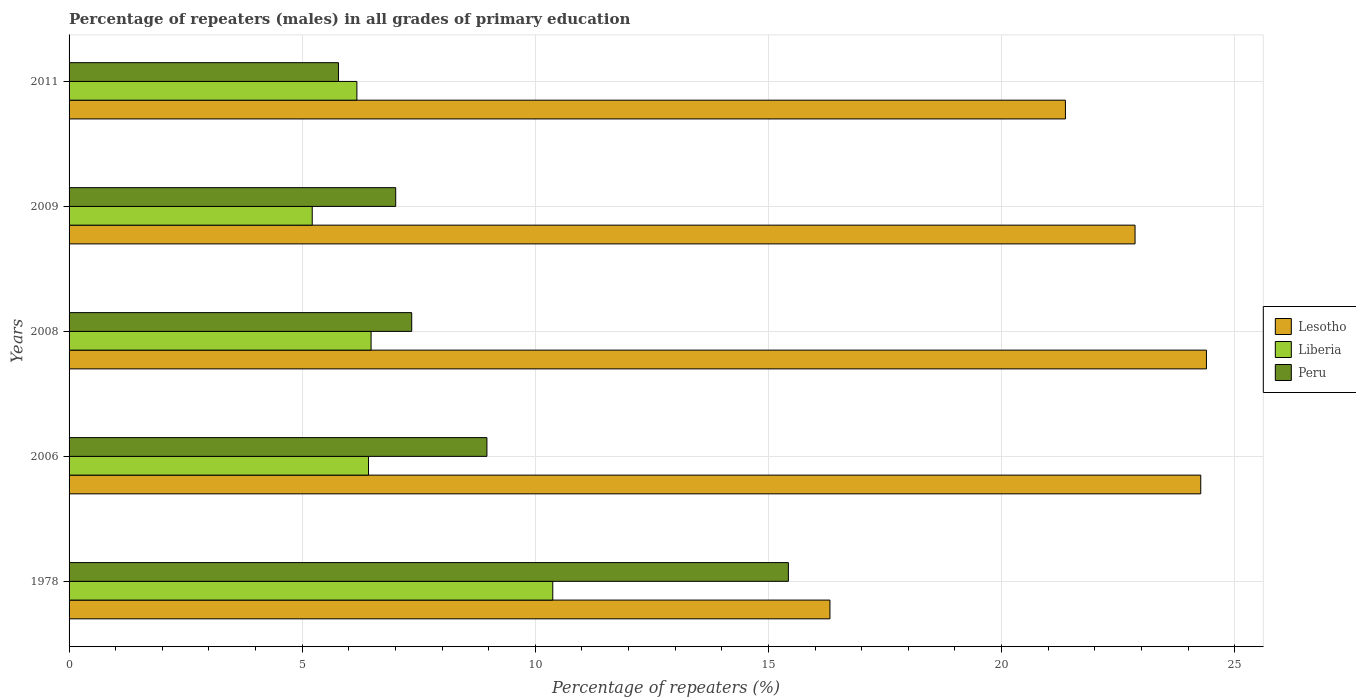How many groups of bars are there?
Offer a very short reply. 5. Are the number of bars on each tick of the Y-axis equal?
Provide a succinct answer. Yes. How many bars are there on the 3rd tick from the top?
Offer a very short reply. 3. How many bars are there on the 1st tick from the bottom?
Ensure brevity in your answer.  3. In how many cases, is the number of bars for a given year not equal to the number of legend labels?
Provide a short and direct response. 0. What is the percentage of repeaters (males) in Lesotho in 2011?
Your response must be concise. 21.37. Across all years, what is the maximum percentage of repeaters (males) in Lesotho?
Your answer should be very brief. 24.39. Across all years, what is the minimum percentage of repeaters (males) in Lesotho?
Keep it short and to the point. 16.32. In which year was the percentage of repeaters (males) in Peru maximum?
Keep it short and to the point. 1978. In which year was the percentage of repeaters (males) in Peru minimum?
Your answer should be very brief. 2011. What is the total percentage of repeaters (males) in Peru in the graph?
Make the answer very short. 44.52. What is the difference between the percentage of repeaters (males) in Peru in 1978 and that in 2006?
Offer a very short reply. 6.47. What is the difference between the percentage of repeaters (males) in Lesotho in 2006 and the percentage of repeaters (males) in Liberia in 2008?
Ensure brevity in your answer.  17.79. What is the average percentage of repeaters (males) in Lesotho per year?
Your response must be concise. 21.84. In the year 2011, what is the difference between the percentage of repeaters (males) in Peru and percentage of repeaters (males) in Liberia?
Your answer should be very brief. -0.4. In how many years, is the percentage of repeaters (males) in Lesotho greater than 16 %?
Your answer should be compact. 5. What is the ratio of the percentage of repeaters (males) in Lesotho in 2008 to that in 2011?
Your answer should be very brief. 1.14. What is the difference between the highest and the second highest percentage of repeaters (males) in Lesotho?
Make the answer very short. 0.12. What is the difference between the highest and the lowest percentage of repeaters (males) in Lesotho?
Offer a very short reply. 8.07. Is the sum of the percentage of repeaters (males) in Liberia in 2009 and 2011 greater than the maximum percentage of repeaters (males) in Peru across all years?
Offer a very short reply. No. What does the 2nd bar from the top in 2011 represents?
Offer a very short reply. Liberia. What does the 3rd bar from the bottom in 2006 represents?
Keep it short and to the point. Peru. Are all the bars in the graph horizontal?
Your answer should be very brief. Yes. Are the values on the major ticks of X-axis written in scientific E-notation?
Keep it short and to the point. No. Where does the legend appear in the graph?
Offer a terse response. Center right. How many legend labels are there?
Provide a succinct answer. 3. How are the legend labels stacked?
Keep it short and to the point. Vertical. What is the title of the graph?
Make the answer very short. Percentage of repeaters (males) in all grades of primary education. What is the label or title of the X-axis?
Ensure brevity in your answer.  Percentage of repeaters (%). What is the Percentage of repeaters (%) in Lesotho in 1978?
Provide a short and direct response. 16.32. What is the Percentage of repeaters (%) of Liberia in 1978?
Your answer should be very brief. 10.37. What is the Percentage of repeaters (%) of Peru in 1978?
Keep it short and to the point. 15.43. What is the Percentage of repeaters (%) of Lesotho in 2006?
Your answer should be compact. 24.27. What is the Percentage of repeaters (%) of Liberia in 2006?
Your answer should be very brief. 6.42. What is the Percentage of repeaters (%) of Peru in 2006?
Give a very brief answer. 8.96. What is the Percentage of repeaters (%) of Lesotho in 2008?
Provide a short and direct response. 24.39. What is the Percentage of repeaters (%) of Liberia in 2008?
Your answer should be very brief. 6.48. What is the Percentage of repeaters (%) of Peru in 2008?
Offer a terse response. 7.35. What is the Percentage of repeaters (%) of Lesotho in 2009?
Give a very brief answer. 22.86. What is the Percentage of repeaters (%) of Liberia in 2009?
Provide a short and direct response. 5.22. What is the Percentage of repeaters (%) in Peru in 2009?
Keep it short and to the point. 7.01. What is the Percentage of repeaters (%) of Lesotho in 2011?
Offer a very short reply. 21.37. What is the Percentage of repeaters (%) in Liberia in 2011?
Your response must be concise. 6.17. What is the Percentage of repeaters (%) in Peru in 2011?
Keep it short and to the point. 5.78. Across all years, what is the maximum Percentage of repeaters (%) of Lesotho?
Your answer should be very brief. 24.39. Across all years, what is the maximum Percentage of repeaters (%) of Liberia?
Keep it short and to the point. 10.37. Across all years, what is the maximum Percentage of repeaters (%) of Peru?
Offer a terse response. 15.43. Across all years, what is the minimum Percentage of repeaters (%) of Lesotho?
Your response must be concise. 16.32. Across all years, what is the minimum Percentage of repeaters (%) in Liberia?
Your answer should be very brief. 5.22. Across all years, what is the minimum Percentage of repeaters (%) in Peru?
Your answer should be compact. 5.78. What is the total Percentage of repeaters (%) of Lesotho in the graph?
Provide a succinct answer. 109.21. What is the total Percentage of repeaters (%) of Liberia in the graph?
Give a very brief answer. 34.66. What is the total Percentage of repeaters (%) of Peru in the graph?
Your answer should be compact. 44.52. What is the difference between the Percentage of repeaters (%) of Lesotho in 1978 and that in 2006?
Make the answer very short. -7.95. What is the difference between the Percentage of repeaters (%) in Liberia in 1978 and that in 2006?
Your response must be concise. 3.95. What is the difference between the Percentage of repeaters (%) of Peru in 1978 and that in 2006?
Provide a short and direct response. 6.47. What is the difference between the Percentage of repeaters (%) of Lesotho in 1978 and that in 2008?
Offer a terse response. -8.07. What is the difference between the Percentage of repeaters (%) of Liberia in 1978 and that in 2008?
Offer a terse response. 3.9. What is the difference between the Percentage of repeaters (%) in Peru in 1978 and that in 2008?
Provide a short and direct response. 8.08. What is the difference between the Percentage of repeaters (%) of Lesotho in 1978 and that in 2009?
Offer a terse response. -6.54. What is the difference between the Percentage of repeaters (%) in Liberia in 1978 and that in 2009?
Make the answer very short. 5.16. What is the difference between the Percentage of repeaters (%) in Peru in 1978 and that in 2009?
Ensure brevity in your answer.  8.42. What is the difference between the Percentage of repeaters (%) of Lesotho in 1978 and that in 2011?
Ensure brevity in your answer.  -5.05. What is the difference between the Percentage of repeaters (%) of Liberia in 1978 and that in 2011?
Provide a short and direct response. 4.2. What is the difference between the Percentage of repeaters (%) of Peru in 1978 and that in 2011?
Ensure brevity in your answer.  9.65. What is the difference between the Percentage of repeaters (%) in Lesotho in 2006 and that in 2008?
Make the answer very short. -0.12. What is the difference between the Percentage of repeaters (%) of Liberia in 2006 and that in 2008?
Your response must be concise. -0.05. What is the difference between the Percentage of repeaters (%) in Peru in 2006 and that in 2008?
Provide a succinct answer. 1.61. What is the difference between the Percentage of repeaters (%) of Lesotho in 2006 and that in 2009?
Your answer should be compact. 1.41. What is the difference between the Percentage of repeaters (%) in Liberia in 2006 and that in 2009?
Keep it short and to the point. 1.21. What is the difference between the Percentage of repeaters (%) in Peru in 2006 and that in 2009?
Provide a short and direct response. 1.96. What is the difference between the Percentage of repeaters (%) in Lesotho in 2006 and that in 2011?
Provide a succinct answer. 2.9. What is the difference between the Percentage of repeaters (%) in Liberia in 2006 and that in 2011?
Provide a short and direct response. 0.25. What is the difference between the Percentage of repeaters (%) in Peru in 2006 and that in 2011?
Provide a succinct answer. 3.18. What is the difference between the Percentage of repeaters (%) of Lesotho in 2008 and that in 2009?
Provide a succinct answer. 1.53. What is the difference between the Percentage of repeaters (%) in Liberia in 2008 and that in 2009?
Provide a succinct answer. 1.26. What is the difference between the Percentage of repeaters (%) of Peru in 2008 and that in 2009?
Your response must be concise. 0.34. What is the difference between the Percentage of repeaters (%) of Lesotho in 2008 and that in 2011?
Give a very brief answer. 3.02. What is the difference between the Percentage of repeaters (%) in Liberia in 2008 and that in 2011?
Provide a short and direct response. 0.3. What is the difference between the Percentage of repeaters (%) of Peru in 2008 and that in 2011?
Keep it short and to the point. 1.57. What is the difference between the Percentage of repeaters (%) of Lesotho in 2009 and that in 2011?
Provide a succinct answer. 1.49. What is the difference between the Percentage of repeaters (%) in Liberia in 2009 and that in 2011?
Ensure brevity in your answer.  -0.96. What is the difference between the Percentage of repeaters (%) in Peru in 2009 and that in 2011?
Offer a very short reply. 1.23. What is the difference between the Percentage of repeaters (%) in Lesotho in 1978 and the Percentage of repeaters (%) in Liberia in 2006?
Make the answer very short. 9.9. What is the difference between the Percentage of repeaters (%) of Lesotho in 1978 and the Percentage of repeaters (%) of Peru in 2006?
Ensure brevity in your answer.  7.36. What is the difference between the Percentage of repeaters (%) in Liberia in 1978 and the Percentage of repeaters (%) in Peru in 2006?
Make the answer very short. 1.41. What is the difference between the Percentage of repeaters (%) of Lesotho in 1978 and the Percentage of repeaters (%) of Liberia in 2008?
Provide a succinct answer. 9.84. What is the difference between the Percentage of repeaters (%) of Lesotho in 1978 and the Percentage of repeaters (%) of Peru in 2008?
Provide a short and direct response. 8.97. What is the difference between the Percentage of repeaters (%) of Liberia in 1978 and the Percentage of repeaters (%) of Peru in 2008?
Your answer should be compact. 3.02. What is the difference between the Percentage of repeaters (%) in Lesotho in 1978 and the Percentage of repeaters (%) in Liberia in 2009?
Offer a very short reply. 11.1. What is the difference between the Percentage of repeaters (%) in Lesotho in 1978 and the Percentage of repeaters (%) in Peru in 2009?
Your answer should be very brief. 9.31. What is the difference between the Percentage of repeaters (%) of Liberia in 1978 and the Percentage of repeaters (%) of Peru in 2009?
Make the answer very short. 3.37. What is the difference between the Percentage of repeaters (%) of Lesotho in 1978 and the Percentage of repeaters (%) of Liberia in 2011?
Offer a very short reply. 10.15. What is the difference between the Percentage of repeaters (%) of Lesotho in 1978 and the Percentage of repeaters (%) of Peru in 2011?
Keep it short and to the point. 10.54. What is the difference between the Percentage of repeaters (%) in Liberia in 1978 and the Percentage of repeaters (%) in Peru in 2011?
Ensure brevity in your answer.  4.6. What is the difference between the Percentage of repeaters (%) in Lesotho in 2006 and the Percentage of repeaters (%) in Liberia in 2008?
Ensure brevity in your answer.  17.79. What is the difference between the Percentage of repeaters (%) in Lesotho in 2006 and the Percentage of repeaters (%) in Peru in 2008?
Your answer should be very brief. 16.92. What is the difference between the Percentage of repeaters (%) of Liberia in 2006 and the Percentage of repeaters (%) of Peru in 2008?
Your answer should be very brief. -0.93. What is the difference between the Percentage of repeaters (%) in Lesotho in 2006 and the Percentage of repeaters (%) in Liberia in 2009?
Your answer should be very brief. 19.06. What is the difference between the Percentage of repeaters (%) in Lesotho in 2006 and the Percentage of repeaters (%) in Peru in 2009?
Your answer should be compact. 17.27. What is the difference between the Percentage of repeaters (%) in Liberia in 2006 and the Percentage of repeaters (%) in Peru in 2009?
Provide a succinct answer. -0.58. What is the difference between the Percentage of repeaters (%) in Lesotho in 2006 and the Percentage of repeaters (%) in Liberia in 2011?
Give a very brief answer. 18.1. What is the difference between the Percentage of repeaters (%) of Lesotho in 2006 and the Percentage of repeaters (%) of Peru in 2011?
Your answer should be compact. 18.49. What is the difference between the Percentage of repeaters (%) of Liberia in 2006 and the Percentage of repeaters (%) of Peru in 2011?
Your response must be concise. 0.64. What is the difference between the Percentage of repeaters (%) of Lesotho in 2008 and the Percentage of repeaters (%) of Liberia in 2009?
Offer a terse response. 19.18. What is the difference between the Percentage of repeaters (%) in Lesotho in 2008 and the Percentage of repeaters (%) in Peru in 2009?
Make the answer very short. 17.39. What is the difference between the Percentage of repeaters (%) of Liberia in 2008 and the Percentage of repeaters (%) of Peru in 2009?
Your answer should be compact. -0.53. What is the difference between the Percentage of repeaters (%) in Lesotho in 2008 and the Percentage of repeaters (%) in Liberia in 2011?
Offer a terse response. 18.22. What is the difference between the Percentage of repeaters (%) in Lesotho in 2008 and the Percentage of repeaters (%) in Peru in 2011?
Make the answer very short. 18.62. What is the difference between the Percentage of repeaters (%) in Liberia in 2008 and the Percentage of repeaters (%) in Peru in 2011?
Ensure brevity in your answer.  0.7. What is the difference between the Percentage of repeaters (%) in Lesotho in 2009 and the Percentage of repeaters (%) in Liberia in 2011?
Keep it short and to the point. 16.69. What is the difference between the Percentage of repeaters (%) in Lesotho in 2009 and the Percentage of repeaters (%) in Peru in 2011?
Your response must be concise. 17.08. What is the difference between the Percentage of repeaters (%) of Liberia in 2009 and the Percentage of repeaters (%) of Peru in 2011?
Give a very brief answer. -0.56. What is the average Percentage of repeaters (%) in Lesotho per year?
Keep it short and to the point. 21.84. What is the average Percentage of repeaters (%) of Liberia per year?
Ensure brevity in your answer.  6.93. What is the average Percentage of repeaters (%) in Peru per year?
Ensure brevity in your answer.  8.9. In the year 1978, what is the difference between the Percentage of repeaters (%) of Lesotho and Percentage of repeaters (%) of Liberia?
Provide a succinct answer. 5.94. In the year 1978, what is the difference between the Percentage of repeaters (%) in Lesotho and Percentage of repeaters (%) in Peru?
Your answer should be very brief. 0.89. In the year 1978, what is the difference between the Percentage of repeaters (%) of Liberia and Percentage of repeaters (%) of Peru?
Make the answer very short. -5.05. In the year 2006, what is the difference between the Percentage of repeaters (%) of Lesotho and Percentage of repeaters (%) of Liberia?
Your answer should be compact. 17.85. In the year 2006, what is the difference between the Percentage of repeaters (%) of Lesotho and Percentage of repeaters (%) of Peru?
Your answer should be very brief. 15.31. In the year 2006, what is the difference between the Percentage of repeaters (%) in Liberia and Percentage of repeaters (%) in Peru?
Provide a short and direct response. -2.54. In the year 2008, what is the difference between the Percentage of repeaters (%) of Lesotho and Percentage of repeaters (%) of Liberia?
Your answer should be very brief. 17.92. In the year 2008, what is the difference between the Percentage of repeaters (%) in Lesotho and Percentage of repeaters (%) in Peru?
Make the answer very short. 17.04. In the year 2008, what is the difference between the Percentage of repeaters (%) in Liberia and Percentage of repeaters (%) in Peru?
Your response must be concise. -0.87. In the year 2009, what is the difference between the Percentage of repeaters (%) in Lesotho and Percentage of repeaters (%) in Liberia?
Make the answer very short. 17.65. In the year 2009, what is the difference between the Percentage of repeaters (%) in Lesotho and Percentage of repeaters (%) in Peru?
Your answer should be compact. 15.86. In the year 2009, what is the difference between the Percentage of repeaters (%) of Liberia and Percentage of repeaters (%) of Peru?
Your response must be concise. -1.79. In the year 2011, what is the difference between the Percentage of repeaters (%) of Lesotho and Percentage of repeaters (%) of Liberia?
Your answer should be compact. 15.2. In the year 2011, what is the difference between the Percentage of repeaters (%) of Lesotho and Percentage of repeaters (%) of Peru?
Your response must be concise. 15.59. In the year 2011, what is the difference between the Percentage of repeaters (%) in Liberia and Percentage of repeaters (%) in Peru?
Your response must be concise. 0.4. What is the ratio of the Percentage of repeaters (%) of Lesotho in 1978 to that in 2006?
Keep it short and to the point. 0.67. What is the ratio of the Percentage of repeaters (%) of Liberia in 1978 to that in 2006?
Make the answer very short. 1.62. What is the ratio of the Percentage of repeaters (%) in Peru in 1978 to that in 2006?
Provide a succinct answer. 1.72. What is the ratio of the Percentage of repeaters (%) in Lesotho in 1978 to that in 2008?
Ensure brevity in your answer.  0.67. What is the ratio of the Percentage of repeaters (%) in Liberia in 1978 to that in 2008?
Provide a short and direct response. 1.6. What is the ratio of the Percentage of repeaters (%) in Peru in 1978 to that in 2008?
Provide a short and direct response. 2.1. What is the ratio of the Percentage of repeaters (%) in Lesotho in 1978 to that in 2009?
Offer a terse response. 0.71. What is the ratio of the Percentage of repeaters (%) of Liberia in 1978 to that in 2009?
Your answer should be very brief. 1.99. What is the ratio of the Percentage of repeaters (%) in Peru in 1978 to that in 2009?
Your answer should be very brief. 2.2. What is the ratio of the Percentage of repeaters (%) of Lesotho in 1978 to that in 2011?
Your answer should be very brief. 0.76. What is the ratio of the Percentage of repeaters (%) of Liberia in 1978 to that in 2011?
Your response must be concise. 1.68. What is the ratio of the Percentage of repeaters (%) of Peru in 1978 to that in 2011?
Offer a terse response. 2.67. What is the ratio of the Percentage of repeaters (%) of Peru in 2006 to that in 2008?
Offer a very short reply. 1.22. What is the ratio of the Percentage of repeaters (%) in Lesotho in 2006 to that in 2009?
Keep it short and to the point. 1.06. What is the ratio of the Percentage of repeaters (%) in Liberia in 2006 to that in 2009?
Your answer should be compact. 1.23. What is the ratio of the Percentage of repeaters (%) in Peru in 2006 to that in 2009?
Your answer should be compact. 1.28. What is the ratio of the Percentage of repeaters (%) of Lesotho in 2006 to that in 2011?
Offer a very short reply. 1.14. What is the ratio of the Percentage of repeaters (%) in Liberia in 2006 to that in 2011?
Provide a succinct answer. 1.04. What is the ratio of the Percentage of repeaters (%) in Peru in 2006 to that in 2011?
Ensure brevity in your answer.  1.55. What is the ratio of the Percentage of repeaters (%) of Lesotho in 2008 to that in 2009?
Offer a terse response. 1.07. What is the ratio of the Percentage of repeaters (%) in Liberia in 2008 to that in 2009?
Keep it short and to the point. 1.24. What is the ratio of the Percentage of repeaters (%) in Peru in 2008 to that in 2009?
Keep it short and to the point. 1.05. What is the ratio of the Percentage of repeaters (%) in Lesotho in 2008 to that in 2011?
Ensure brevity in your answer.  1.14. What is the ratio of the Percentage of repeaters (%) of Liberia in 2008 to that in 2011?
Ensure brevity in your answer.  1.05. What is the ratio of the Percentage of repeaters (%) in Peru in 2008 to that in 2011?
Your response must be concise. 1.27. What is the ratio of the Percentage of repeaters (%) of Lesotho in 2009 to that in 2011?
Provide a succinct answer. 1.07. What is the ratio of the Percentage of repeaters (%) of Liberia in 2009 to that in 2011?
Your response must be concise. 0.84. What is the ratio of the Percentage of repeaters (%) of Peru in 2009 to that in 2011?
Give a very brief answer. 1.21. What is the difference between the highest and the second highest Percentage of repeaters (%) in Lesotho?
Ensure brevity in your answer.  0.12. What is the difference between the highest and the second highest Percentage of repeaters (%) in Liberia?
Your answer should be very brief. 3.9. What is the difference between the highest and the second highest Percentage of repeaters (%) in Peru?
Ensure brevity in your answer.  6.47. What is the difference between the highest and the lowest Percentage of repeaters (%) of Lesotho?
Ensure brevity in your answer.  8.07. What is the difference between the highest and the lowest Percentage of repeaters (%) in Liberia?
Make the answer very short. 5.16. What is the difference between the highest and the lowest Percentage of repeaters (%) of Peru?
Your answer should be compact. 9.65. 